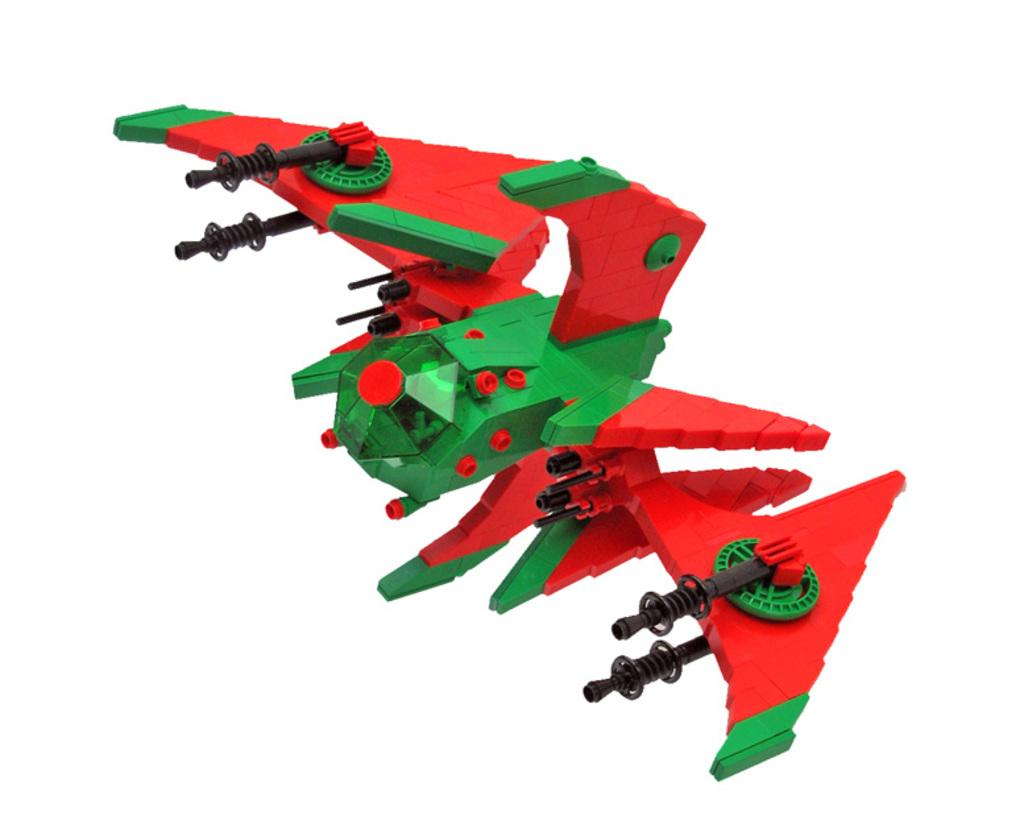What is the main subject of the image? The main subject of the image is a lego toy. What color is the background of the image? The background of the image is white in color. What type of produce can be seen growing in the image? There is no produce present in the image; it features a lego toy. What type of jewel is visible on the lego toy in the image? There is no jewel present on the lego toy in the image. 